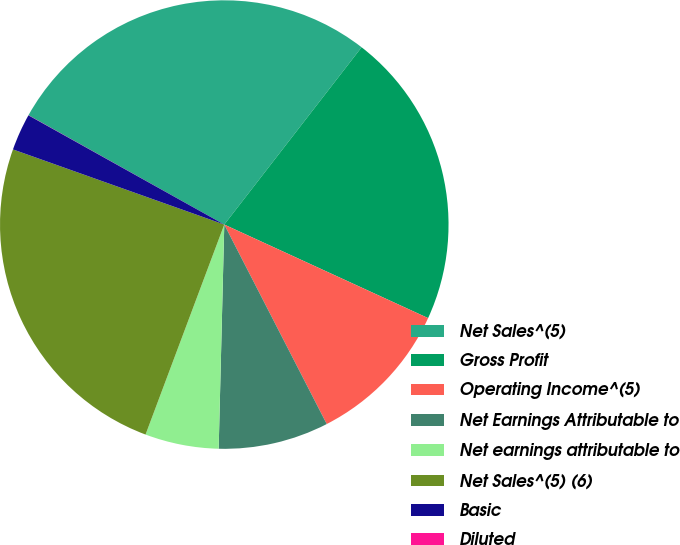Convert chart to OTSL. <chart><loc_0><loc_0><loc_500><loc_500><pie_chart><fcel>Net Sales^(5)<fcel>Gross Profit<fcel>Operating Income^(5)<fcel>Net Earnings Attributable to<fcel>Net earnings attributable to<fcel>Net Sales^(5) (6)<fcel>Basic<fcel>Diluted<nl><fcel>27.38%<fcel>21.36%<fcel>10.6%<fcel>7.95%<fcel>5.31%<fcel>24.73%<fcel>2.66%<fcel>0.01%<nl></chart> 